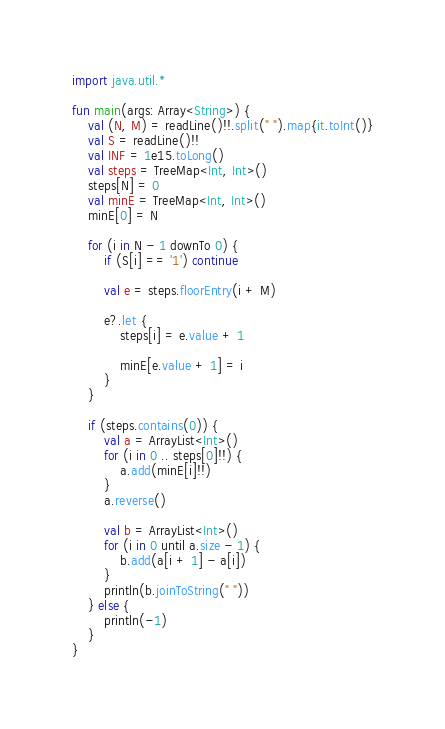Convert code to text. <code><loc_0><loc_0><loc_500><loc_500><_Kotlin_>import java.util.*

fun main(args: Array<String>) {
    val (N, M) = readLine()!!.split(" ").map{it.toInt()}
    val S = readLine()!!
    val INF = 1e15.toLong()
    val steps = TreeMap<Int, Int>()
    steps[N] = 0
    val minE = TreeMap<Int, Int>()
    minE[0] = N

    for (i in N - 1 downTo 0) {
        if (S[i] == '1') continue

        val e = steps.floorEntry(i + M)

        e?.let {
            steps[i] = e.value + 1

            minE[e.value + 1] = i
        }
    }

    if (steps.contains(0)) {
        val a = ArrayList<Int>()
        for (i in 0 .. steps[0]!!) {
            a.add(minE[i]!!)
        }
        a.reverse()

        val b = ArrayList<Int>()
        for (i in 0 until a.size - 1) {
            b.add(a[i + 1] - a[i])
        }
        println(b.joinToString(" "))
    } else {
        println(-1)
    }
}
</code> 